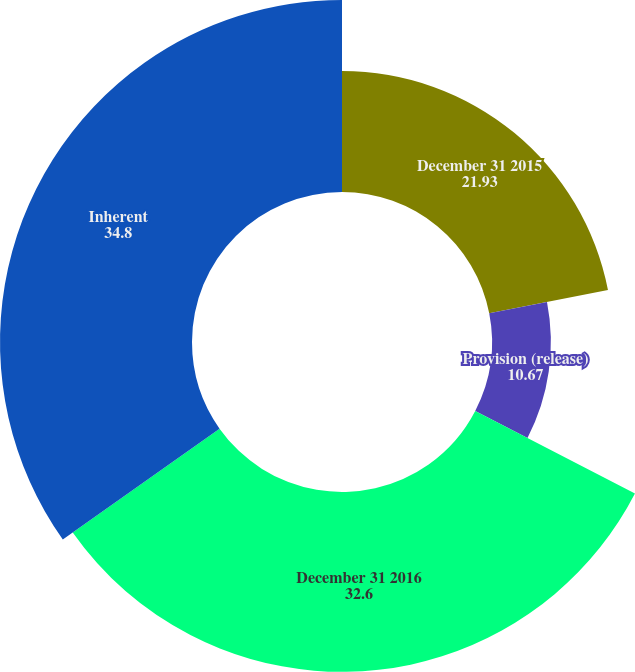Convert chart. <chart><loc_0><loc_0><loc_500><loc_500><pie_chart><fcel>December 31 2015<fcel>Provision (release)<fcel>December 31 2016<fcel>Inherent<nl><fcel>21.93%<fcel>10.67%<fcel>32.6%<fcel>34.8%<nl></chart> 